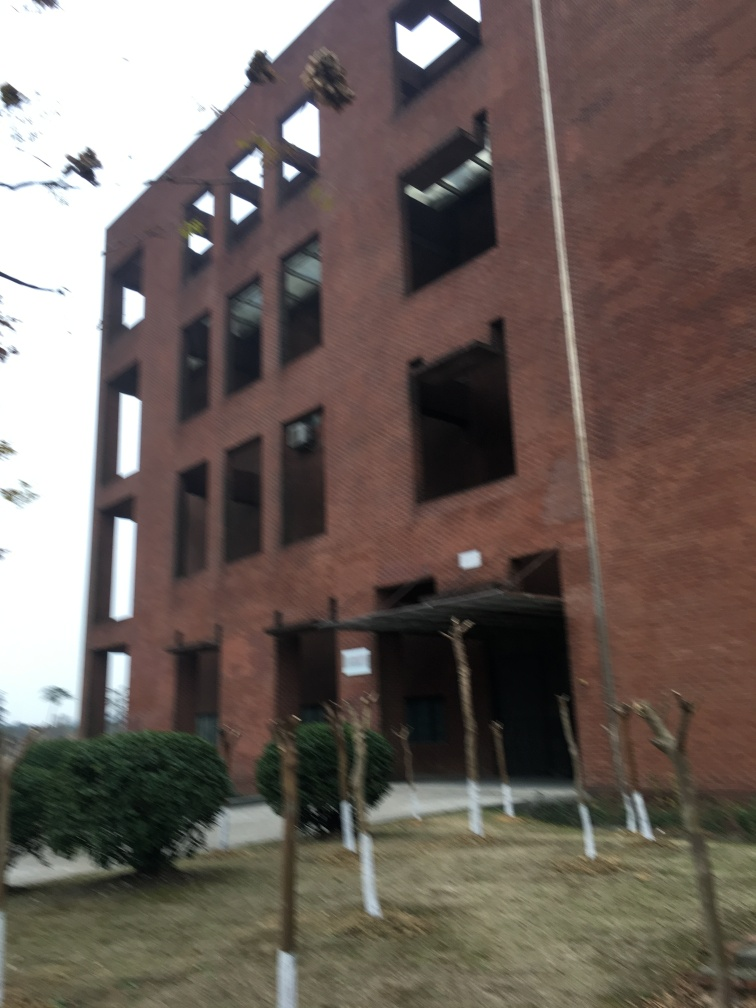How would you describe the sky in the image? The sky in the image is challenging to assess due to the blurriness and perspective, but there are no visible signs of cloud formations or distinct details that can conclusively point towards a cloudy or clear sky. The focus appears to be more on the building rather than the sky. 